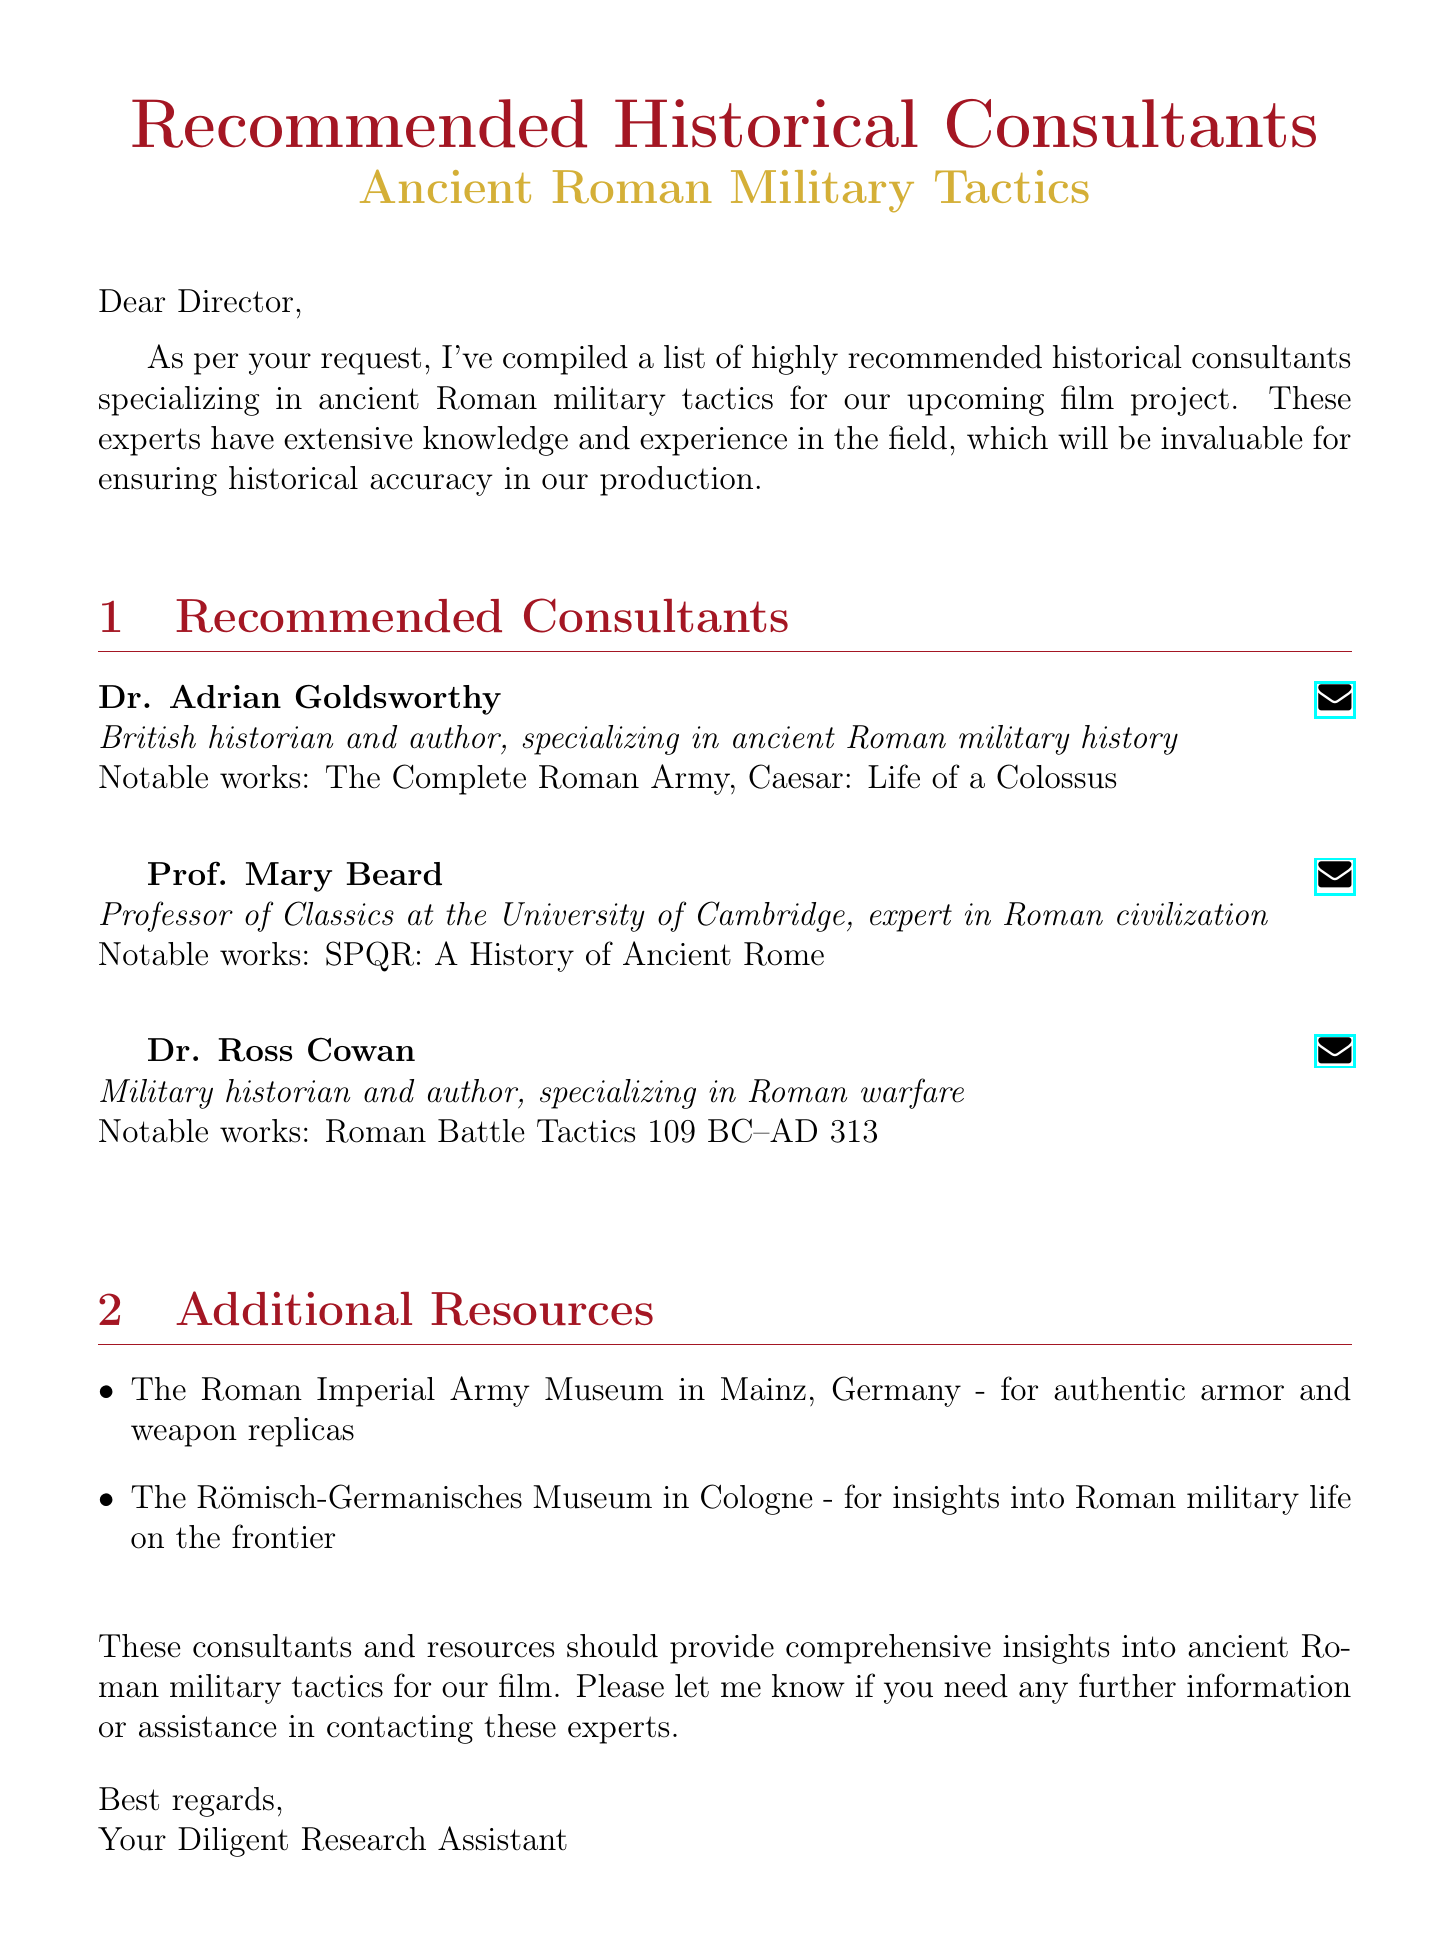What is the subject of the email? The subject line provides the main topic discussed in the email, which is about historical consultants.
Answer: Recommended Historical Consultants for Ancient Roman Military Tactics Who is the first consultant listed? The email enumerates the consultants in a specific order, with the first being Dr. Adrian Goldsworthy.
Answer: Dr. Adrian Goldsworthy What notable work is associated with Prof. Mary Beard? The email mentions specific works to highlight each consultant's contributions, with Prof. Mary Beard's notable work being referenced.
Answer: SPQR: A History of Ancient Rome How many consultants are recommended in the email? The email lists the number of consultants and their details, allowing us to count them directly.
Answer: Three What type of museum is mentioned in the additional resources? The email provides specific resources, including museums, indicating their purposes related to military history.
Answer: The Roman Imperial Army Museum What is the occupation of Dr. Ross Cowan? The credentials section describes the role of each consultant, revealing their area of expertise.
Answer: Military historian What is the primary focus of the historical consultants? The introduction outlines the main area of specialization for the consultants, which is crucial for film accuracy.
Answer: Ancient Roman military tactics What is the closing remark of the email? The final section contains a concluding statement that reflects the intention to assist further.
Answer: These consultants and resources should provide comprehensive insights into ancient Roman military tactics for our film 